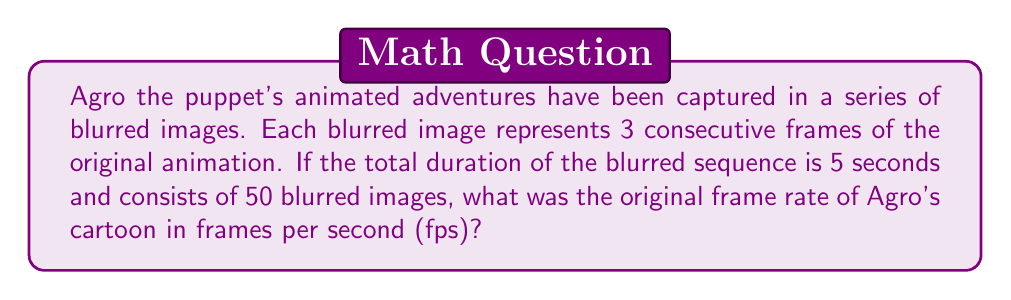Teach me how to tackle this problem. Let's approach this step-by-step:

1) First, let's define our variables:
   Let $x$ be the original frame rate in fps.
   Let $n$ be the number of frames in the original animation.

2) We know that each blurred image represents 3 consecutive frames. So, the number of original frames is:
   $n = 50 \times 3 = 150$ frames

3) We also know that the total duration is 5 seconds. The relationship between frames, frame rate, and time is:
   $n = x \times t$
   Where $n$ is the number of frames, $x$ is the frame rate, and $t$ is the time in seconds.

4) Substituting our known values:
   $150 = x \times 5$

5) Solving for $x$:
   $x = \frac{150}{5} = 30$

Therefore, the original frame rate was 30 fps.
Answer: 30 fps 